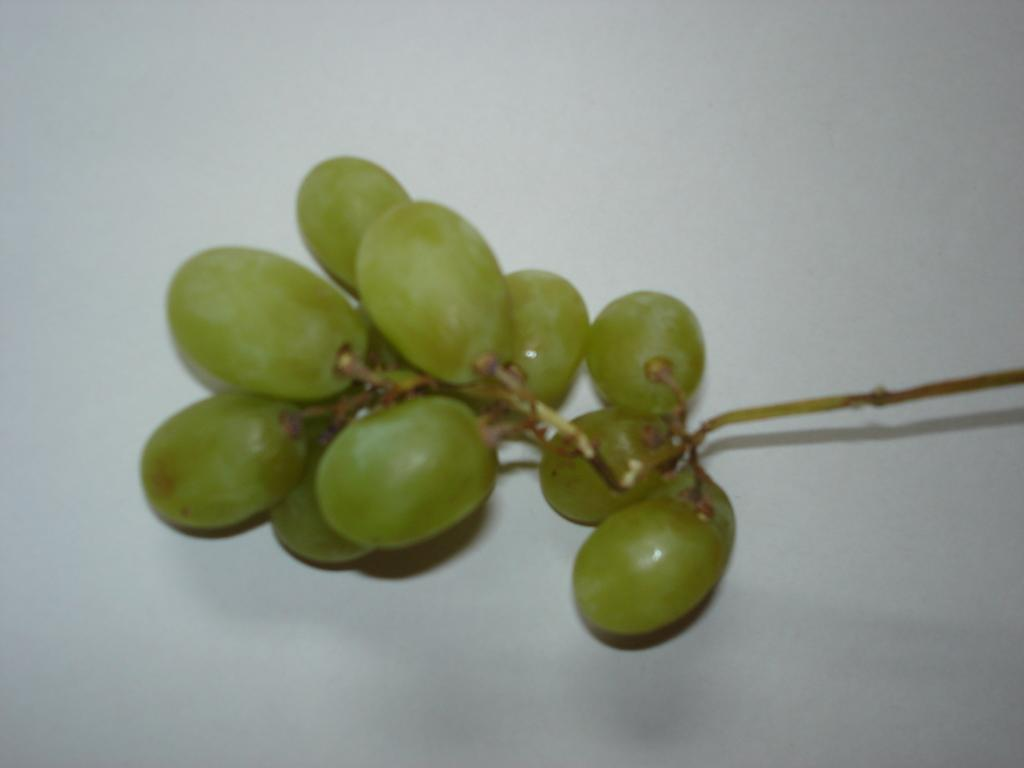What type of fruit is visible in the image? There is a bunch of grapes in the image. What is the bunch of grapes resting on in the image? The bunch of grapes is on a white object. What type of instrument is used to extract honey from the grapes in the image? There is no instrument or honey present in the image; it only features a bunch of grapes on a white object. 